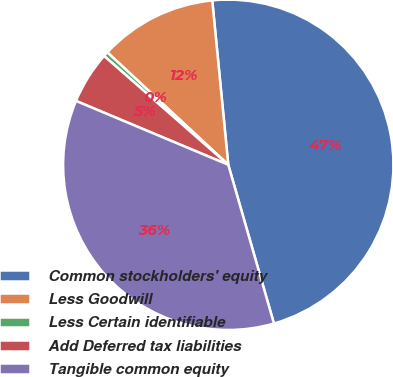Convert chart to OTSL. <chart><loc_0><loc_0><loc_500><loc_500><pie_chart><fcel>Common stockholders' equity<fcel>Less Goodwill<fcel>Less Certain identifiable<fcel>Add Deferred tax liabilities<fcel>Tangible common equity<nl><fcel>47.09%<fcel>11.53%<fcel>0.47%<fcel>5.13%<fcel>35.78%<nl></chart> 